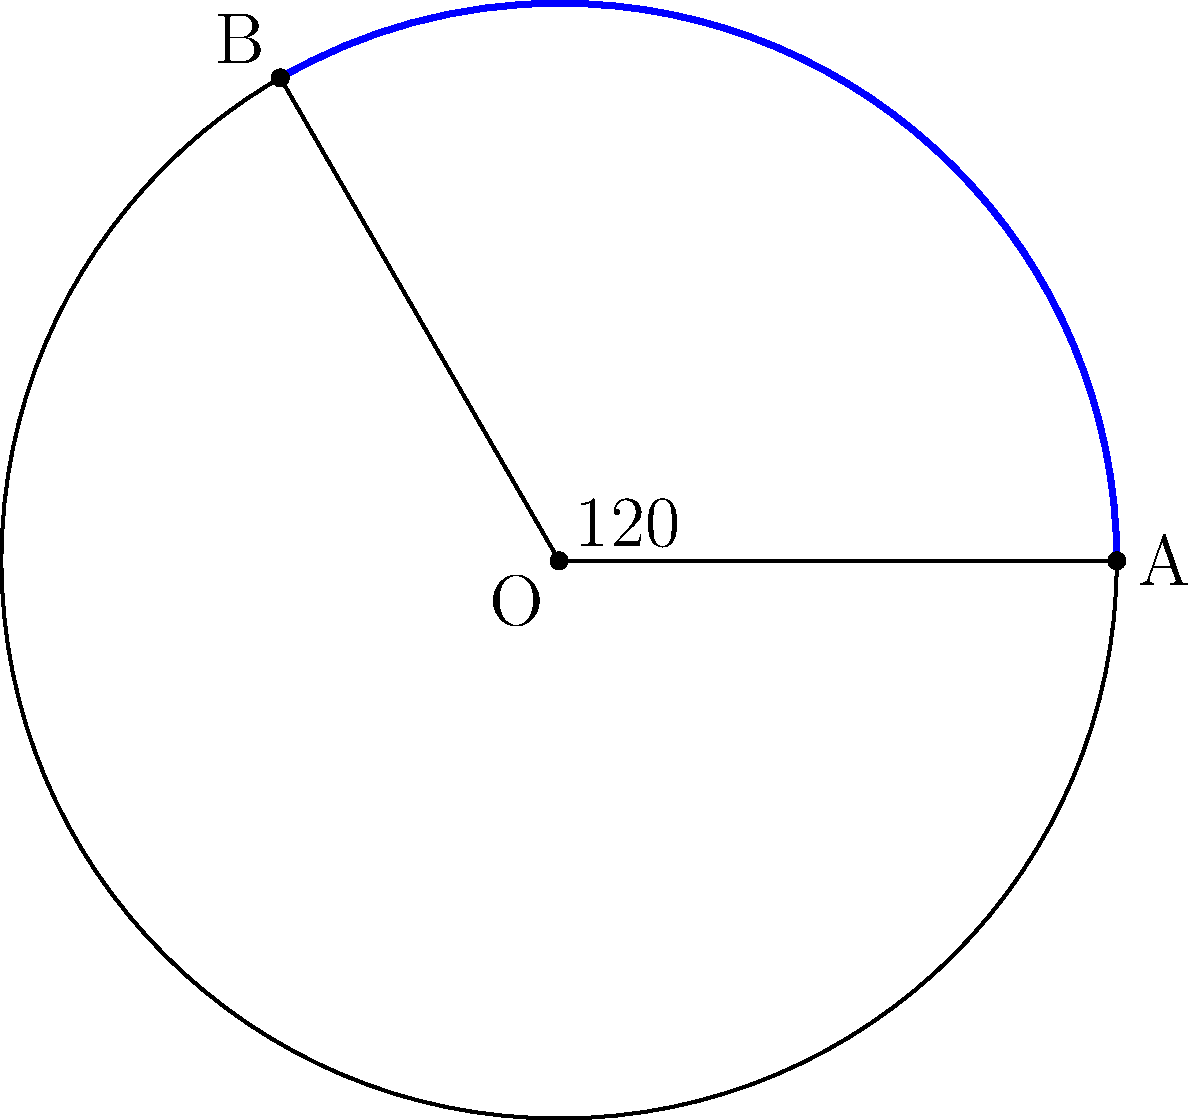In a circular humanitarian aid distribution zone, a sector with a central angle of 120° is designated for medical supplies. If the total area of the distribution zone is 254.47 square kilometers, what is the area of the sector allocated for medical supplies? Round your answer to two decimal places. Let's approach this step-by-step:

1) First, we need to recall the formula for the area of a circular sector:

   Area of sector = $\frac{\theta}{360°} \times \pi r^2$

   where $\theta$ is the central angle in degrees and $r$ is the radius of the circle.

2) We're given the central angle $\theta = 120°$, but we don't know the radius. However, we can find it from the total area of the circle.

3) The total area of a circle is given by $A = \pi r^2$. We're told this is 254.47 sq km.

4) So, $254.47 = \pi r^2$

5) Solving for $r$:
   $r^2 = \frac{254.47}{\pi}$
   $r = \sqrt{\frac{254.47}{\pi}} \approx 9$ km

6) Now we can use the sector area formula:

   Area of sector = $\frac{120°}{360°} \times \pi (9^2)$
                  = $\frac{1}{3} \times \pi \times 81$
                  = $27\pi$
                  $\approx 84.82$ sq km

7) Rounding to two decimal places: 84.82 sq km

This area represents the zone allocated for medical supplies distribution.
Answer: 84.82 sq km 